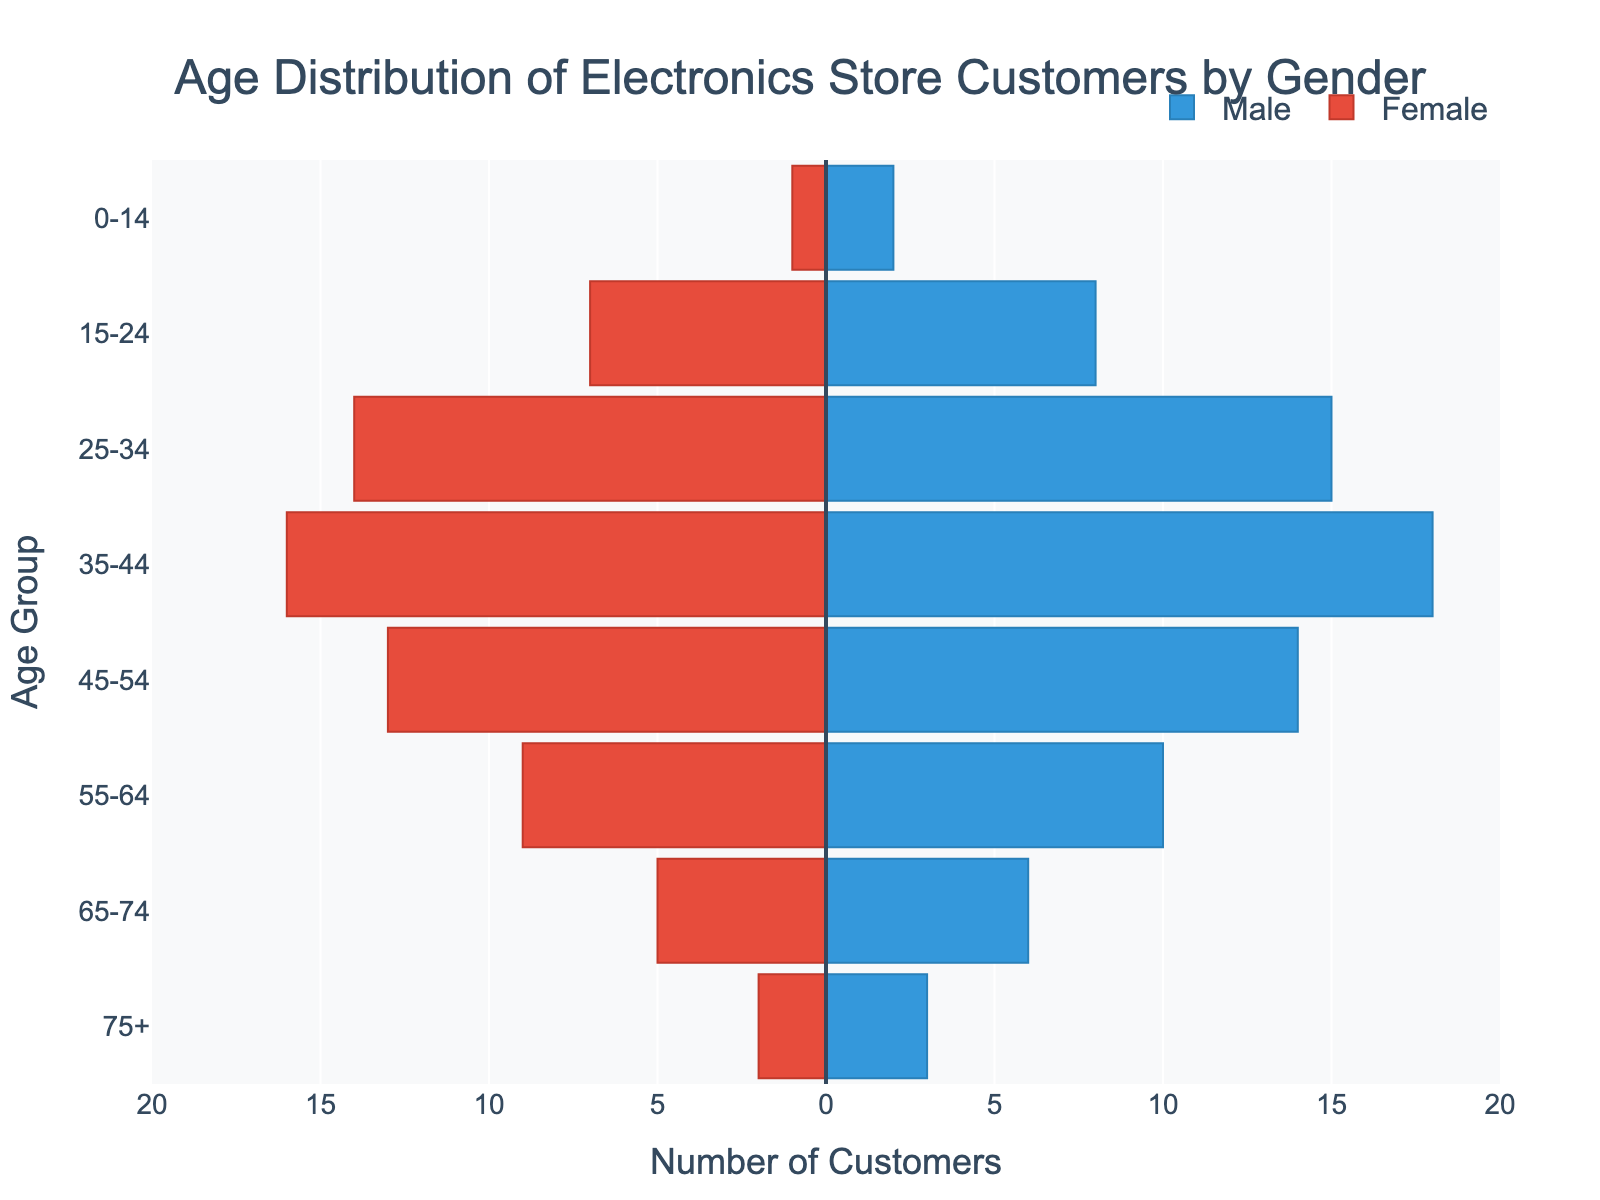What is the title of the plot? The title of the plot is located at the top of the figure and states the main context of the data visualization.
Answer: Age Distribution of Electronics Store Customers by Gender Which age group has the highest number of male customers? By looking at the bars representing males, the age group with the longest horizontal bar indicates the highest number of male customers. The 35-44 age group has the longest male bar.
Answer: 35-44 How many total customers are there in the 25-34 age group? To find the total, add the number of male (15) and female (14) customers in the 25-34 age group. 15 + 14 = 29.
Answer: 29 What is the difference in the number of customers between males and females in the 55-64 age group? Look at the corresponding bars for males and females in the 55-64 age group and compute the difference (10 for males and 9 for females). 10 - 9 = 1.
Answer: 1 Which gender has more customers in the 65-74 age group? Compare the lengths of the bars for males and females in the 65-74 age group. The male bar is longer.
Answer: Male What age group has the smallest total number of customers? Sum the male and female customers for each age group and find the smallest total. The 75+ age group has the fewest total customers (3 males + 2 females = 5).
Answer: 75+ What is the total number of female customers across all age groups? Sum the number of female customers across all age groups: 1 + 7 + 14 + 16 + 13 + 9 + 5 + 2. The total is 67.
Answer: 67 Compare the number of customers in the 0-14 age group to those in the 15-24 age group. Calculate the totals for both age groups: 0-14 (2 males + 1 female = 3) and 15-24 (8 males + 7 females = 15). The 15-24 age group has more customers (15 compared to 3).
Answer: 15-24 What is the average number of customers per age group for males? Add the number of male customers across all age groups and divide by the number of age groups: (2 + 8 + 15 + 18 + 14 + 10 + 6 + 3) / 8. The sum is 76, so the average is 76 / 8 = 9.5.
Answer: 9.5 